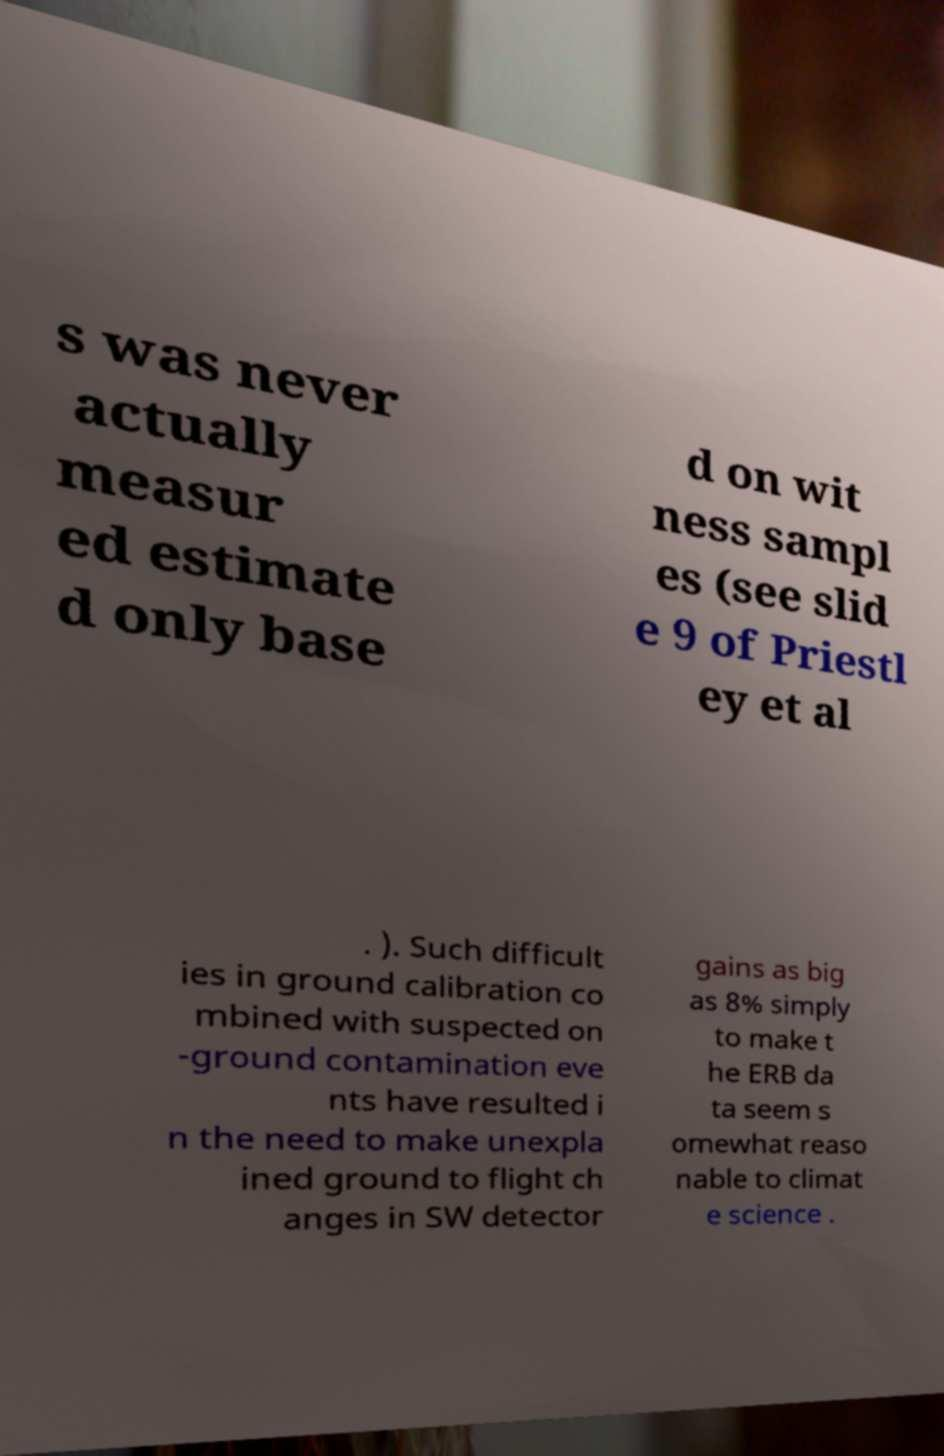There's text embedded in this image that I need extracted. Can you transcribe it verbatim? s was never actually measur ed estimate d only base d on wit ness sampl es (see slid e 9 of Priestl ey et al . ). Such difficult ies in ground calibration co mbined with suspected on -ground contamination eve nts have resulted i n the need to make unexpla ined ground to flight ch anges in SW detector gains as big as 8% simply to make t he ERB da ta seem s omewhat reaso nable to climat e science . 